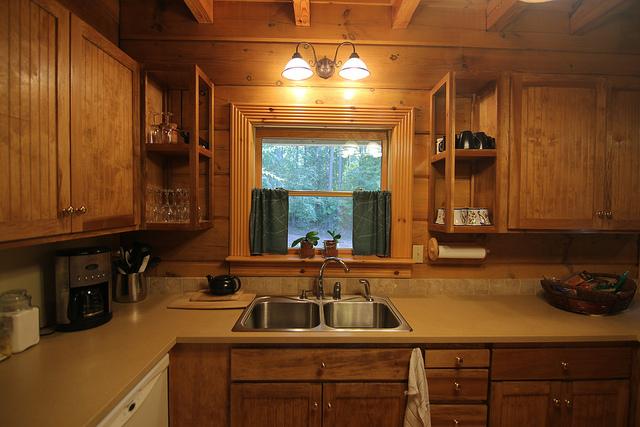Where are the wine glasses?
Short answer required. Shelf. Is this an old-fashioned kitchen?
Write a very short answer. Yes. Does a slob use this kitchen?
Concise answer only. No. How many lights are there in the room?
Give a very brief answer. 2. 